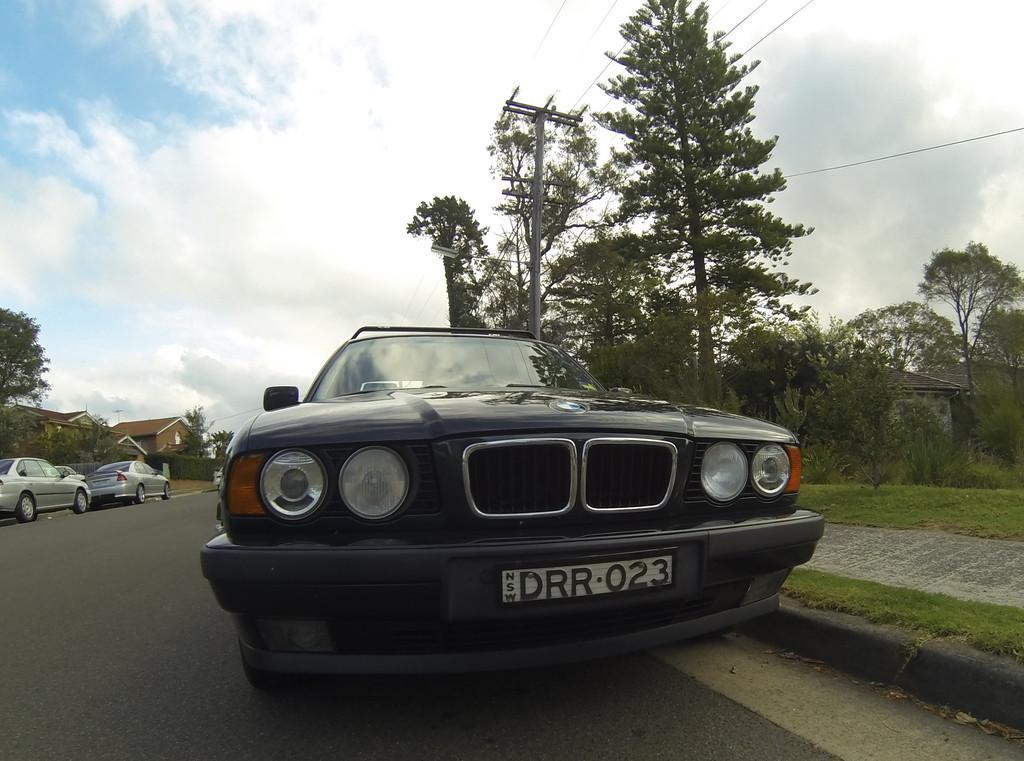In one or two sentences, can you explain what this image depicts? In this image we can see cars, grass, plants, houses, road, and trees. In the background there is sky with clouds. 